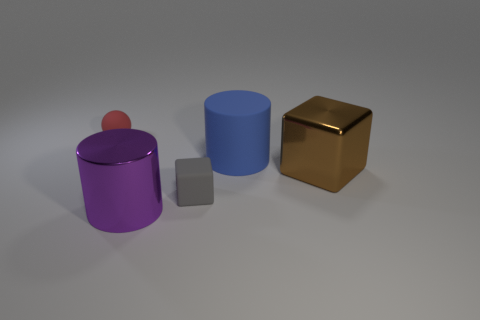There is a red sphere; what number of large blue objects are to the right of it?
Make the answer very short. 1. Does the purple metallic object have the same shape as the big matte thing?
Your answer should be compact. Yes. What number of rubber objects are both behind the brown metal block and in front of the sphere?
Make the answer very short. 1. How many things are large brown metal cubes or objects on the right side of the purple shiny thing?
Offer a terse response. 3. Are there more brown shiny cubes than big purple matte objects?
Provide a succinct answer. Yes. The tiny matte thing in front of the large brown metallic object has what shape?
Give a very brief answer. Cube. How many other large rubber things have the same shape as the big blue object?
Your answer should be very brief. 0. What size is the cylinder on the right side of the big metal thing that is left of the rubber block?
Your response must be concise. Large. How many green objects are either large rubber things or shiny cubes?
Ensure brevity in your answer.  0. Are there fewer blue rubber things that are behind the rubber sphere than red matte balls right of the blue matte thing?
Provide a short and direct response. No. 